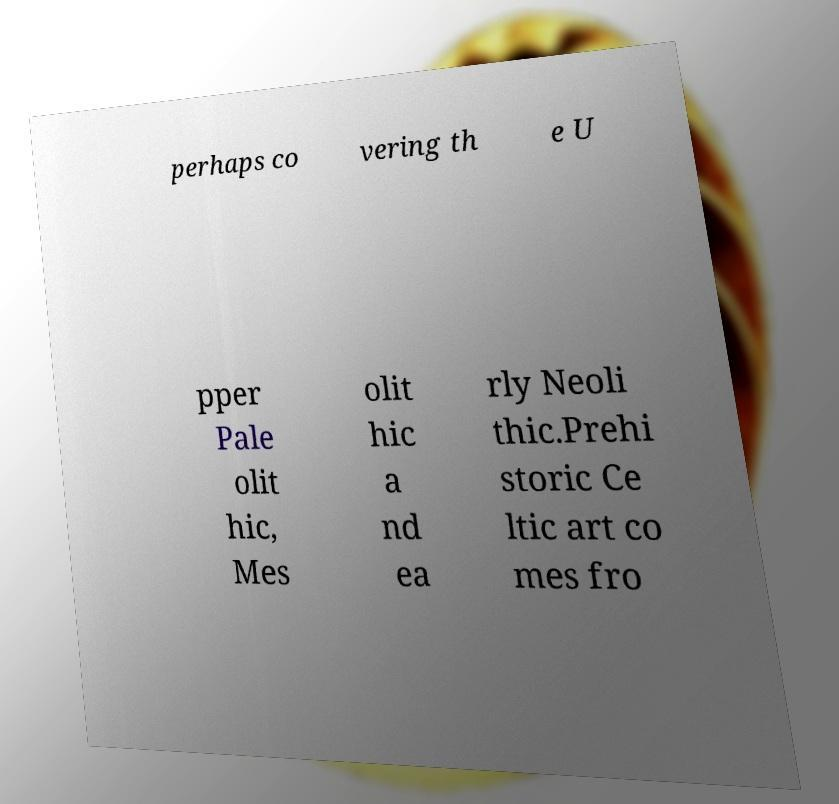Can you accurately transcribe the text from the provided image for me? perhaps co vering th e U pper Pale olit hic, Mes olit hic a nd ea rly Neoli thic.Prehi storic Ce ltic art co mes fro 